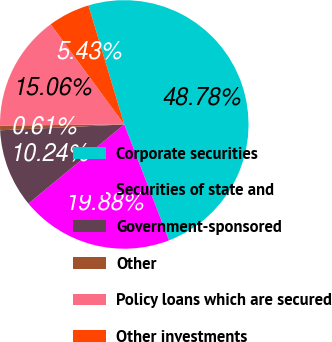Convert chart. <chart><loc_0><loc_0><loc_500><loc_500><pie_chart><fcel>Corporate securities<fcel>Securities of state and<fcel>Government-sponsored<fcel>Other<fcel>Policy loans which are secured<fcel>Other investments<nl><fcel>48.78%<fcel>19.88%<fcel>10.24%<fcel>0.61%<fcel>15.06%<fcel>5.43%<nl></chart> 